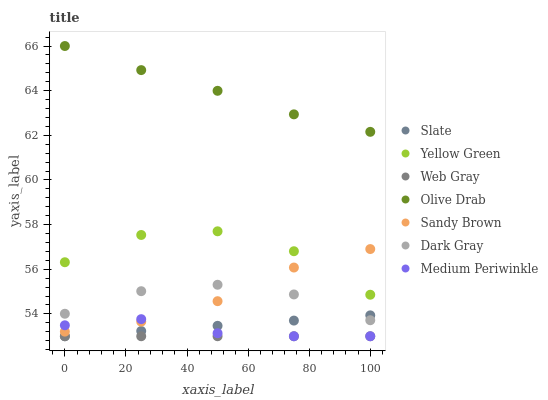Does Web Gray have the minimum area under the curve?
Answer yes or no. Yes. Does Olive Drab have the maximum area under the curve?
Answer yes or no. Yes. Does Yellow Green have the minimum area under the curve?
Answer yes or no. No. Does Yellow Green have the maximum area under the curve?
Answer yes or no. No. Is Web Gray the smoothest?
Answer yes or no. Yes. Is Yellow Green the roughest?
Answer yes or no. Yes. Is Slate the smoothest?
Answer yes or no. No. Is Slate the roughest?
Answer yes or no. No. Does Web Gray have the lowest value?
Answer yes or no. Yes. Does Yellow Green have the lowest value?
Answer yes or no. No. Does Olive Drab have the highest value?
Answer yes or no. Yes. Does Yellow Green have the highest value?
Answer yes or no. No. Is Web Gray less than Sandy Brown?
Answer yes or no. Yes. Is Yellow Green greater than Web Gray?
Answer yes or no. Yes. Does Sandy Brown intersect Medium Periwinkle?
Answer yes or no. Yes. Is Sandy Brown less than Medium Periwinkle?
Answer yes or no. No. Is Sandy Brown greater than Medium Periwinkle?
Answer yes or no. No. Does Web Gray intersect Sandy Brown?
Answer yes or no. No. 